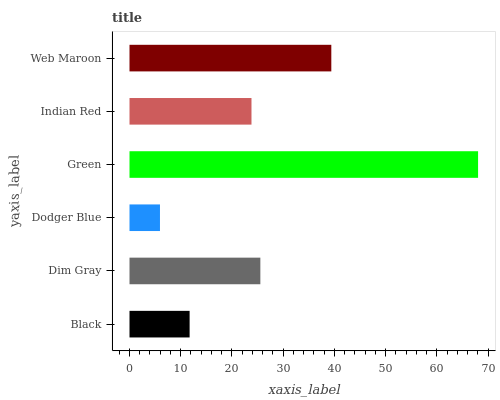Is Dodger Blue the minimum?
Answer yes or no. Yes. Is Green the maximum?
Answer yes or no. Yes. Is Dim Gray the minimum?
Answer yes or no. No. Is Dim Gray the maximum?
Answer yes or no. No. Is Dim Gray greater than Black?
Answer yes or no. Yes. Is Black less than Dim Gray?
Answer yes or no. Yes. Is Black greater than Dim Gray?
Answer yes or no. No. Is Dim Gray less than Black?
Answer yes or no. No. Is Dim Gray the high median?
Answer yes or no. Yes. Is Indian Red the low median?
Answer yes or no. Yes. Is Black the high median?
Answer yes or no. No. Is Web Maroon the low median?
Answer yes or no. No. 